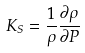Convert formula to latex. <formula><loc_0><loc_0><loc_500><loc_500>K _ { S } = \frac { 1 } { \rho } \frac { \partial \rho } { \partial P }</formula> 